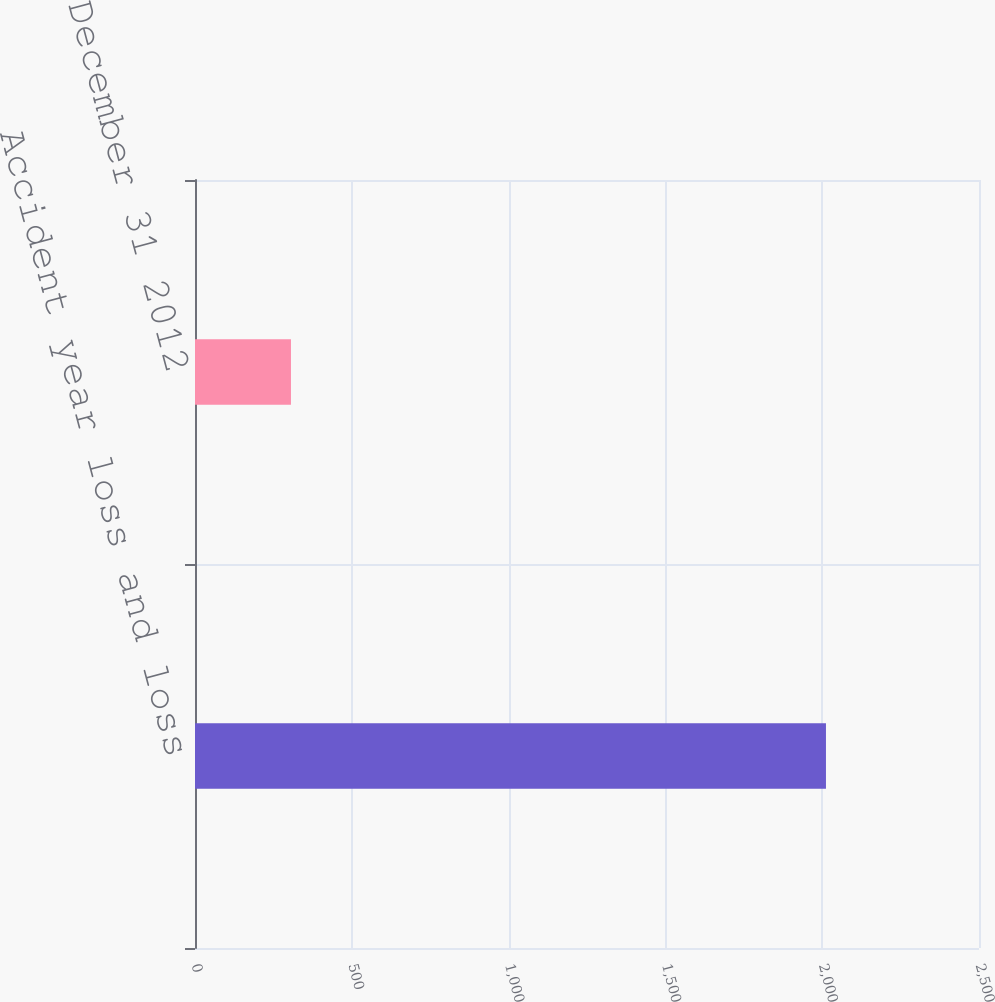<chart> <loc_0><loc_0><loc_500><loc_500><bar_chart><fcel>Accident year loss and loss<fcel>as of December 31 2012<nl><fcel>2012<fcel>306<nl></chart> 